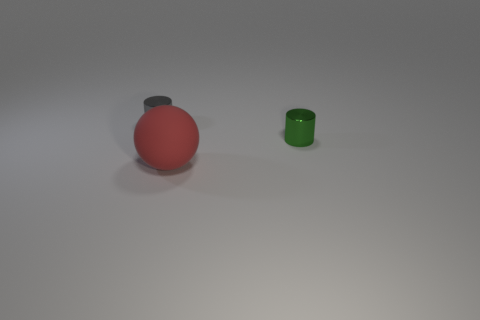Add 2 large green rubber cylinders. How many objects exist? 5 Subtract all purple cylinders. How many gray spheres are left? 0 Subtract all small gray cylinders. Subtract all green things. How many objects are left? 1 Add 2 gray objects. How many gray objects are left? 3 Add 1 red rubber objects. How many red rubber objects exist? 2 Subtract 0 gray balls. How many objects are left? 3 Subtract all spheres. How many objects are left? 2 Subtract 1 spheres. How many spheres are left? 0 Subtract all purple balls. Subtract all red blocks. How many balls are left? 1 